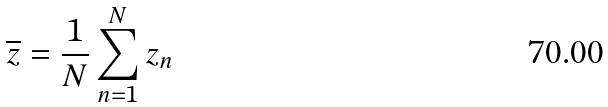<formula> <loc_0><loc_0><loc_500><loc_500>\overline { z } = \frac { 1 } { N } \sum _ { n = 1 } ^ { N } z _ { n }</formula> 